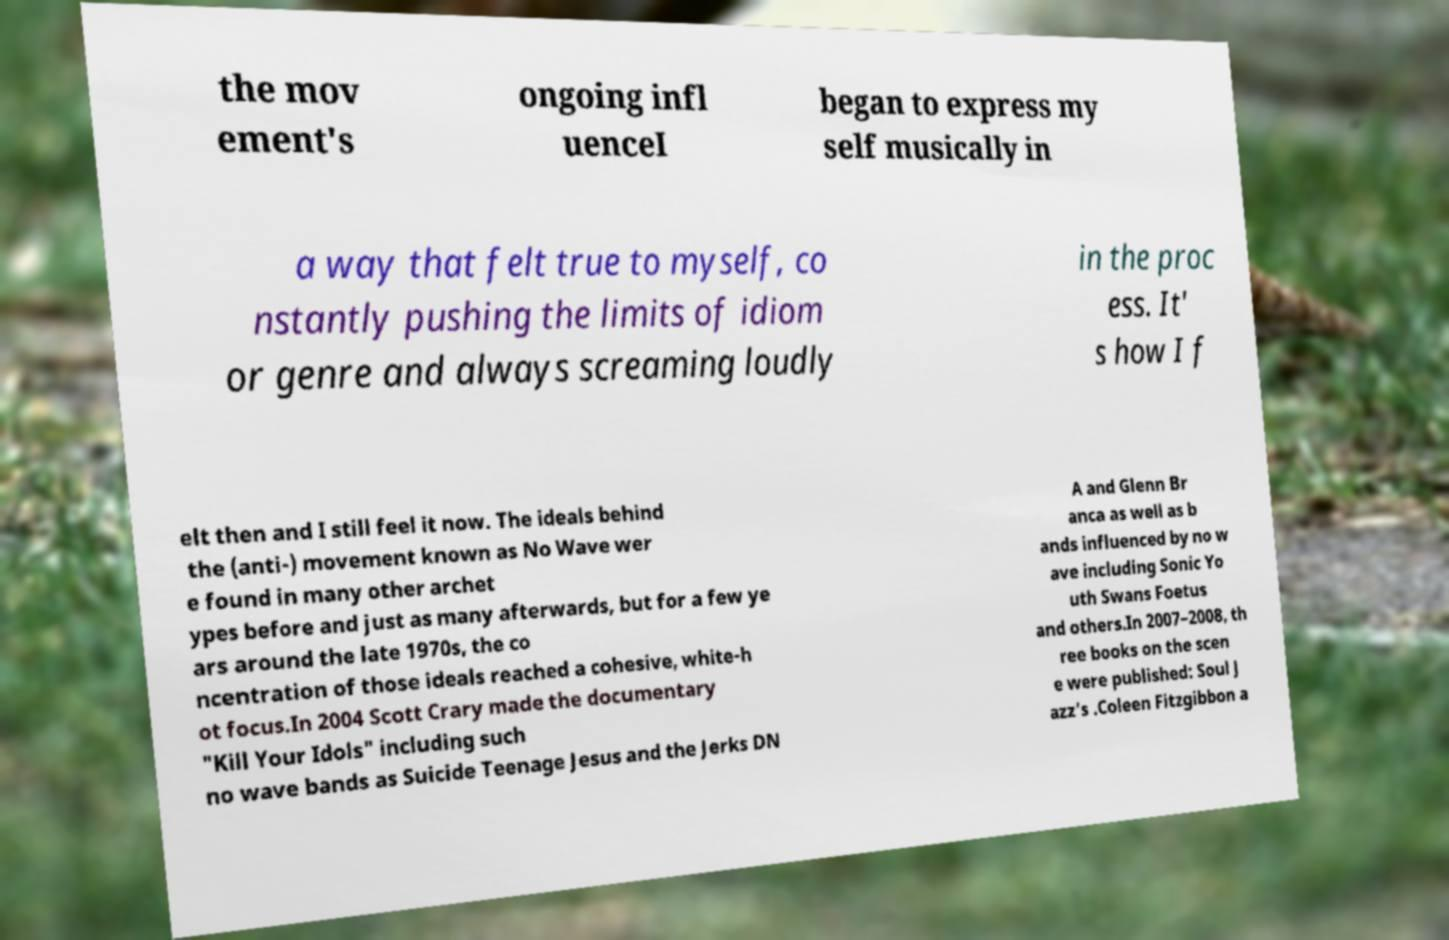Could you assist in decoding the text presented in this image and type it out clearly? the mov ement's ongoing infl uenceI began to express my self musically in a way that felt true to myself, co nstantly pushing the limits of idiom or genre and always screaming loudly in the proc ess. It' s how I f elt then and I still feel it now. The ideals behind the (anti-) movement known as No Wave wer e found in many other archet ypes before and just as many afterwards, but for a few ye ars around the late 1970s, the co ncentration of those ideals reached a cohesive, white-h ot focus.In 2004 Scott Crary made the documentary "Kill Your Idols" including such no wave bands as Suicide Teenage Jesus and the Jerks DN A and Glenn Br anca as well as b ands influenced by no w ave including Sonic Yo uth Swans Foetus and others.In 2007–2008, th ree books on the scen e were published: Soul J azz's .Coleen Fitzgibbon a 